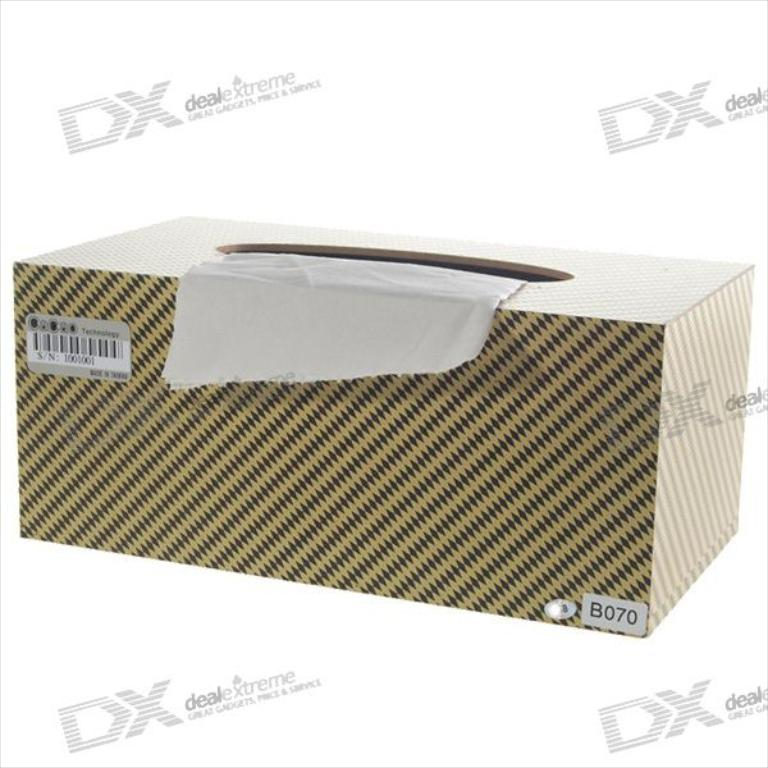How can the unique packaging of this product influence consumer perception? Distinctive packaging, like the houndstooth pattern seen here, can make a product more memorable and visually appealing, potentially enhancing consumer trust and interest by standing out in a crowded market. 